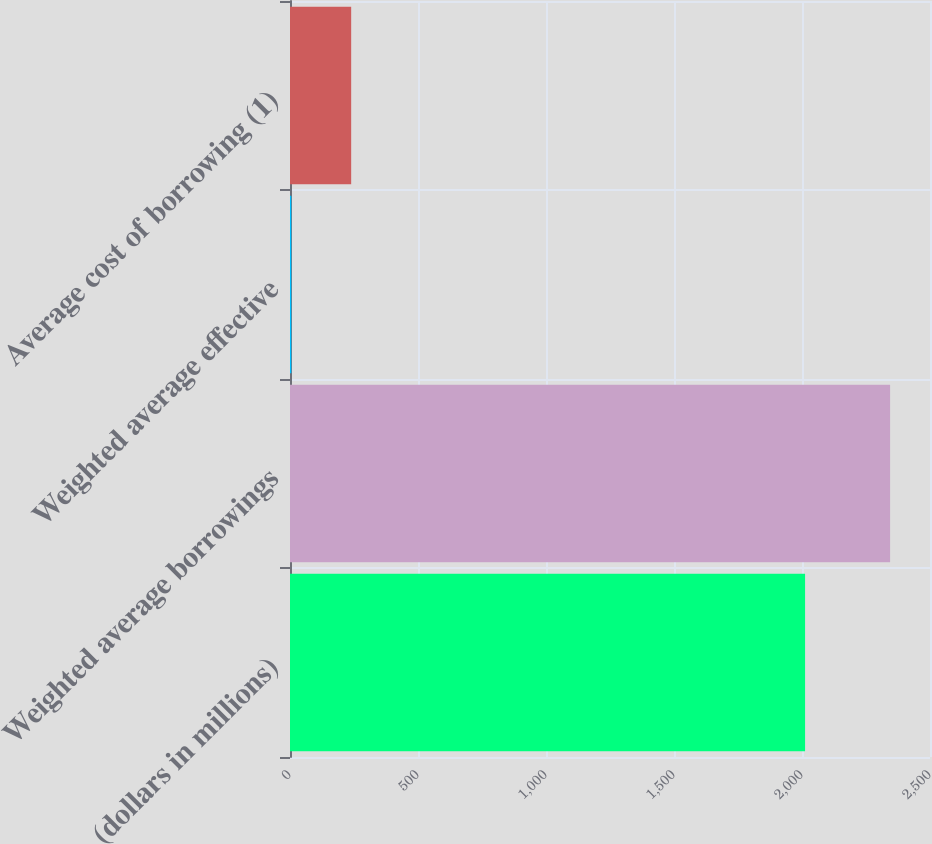Convert chart to OTSL. <chart><loc_0><loc_0><loc_500><loc_500><bar_chart><fcel>(dollars in millions)<fcel>Weighted average borrowings<fcel>Weighted average effective<fcel>Average cost of borrowing (1)<nl><fcel>2012<fcel>2344.1<fcel>5.06<fcel>238.96<nl></chart> 